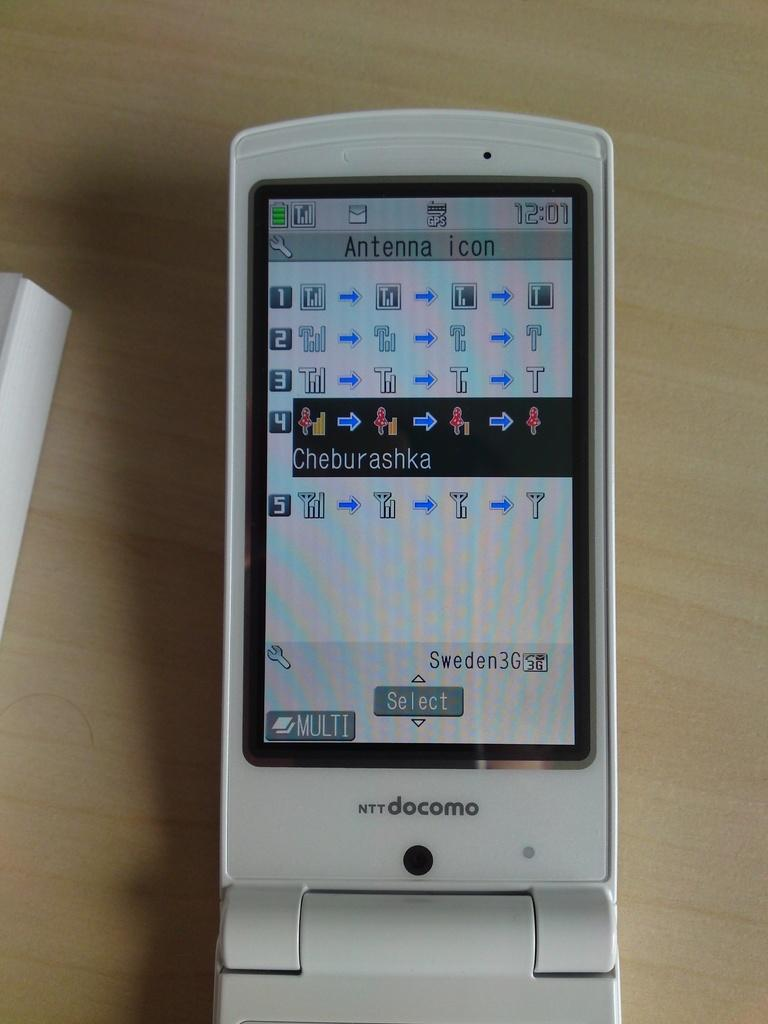Provide a one-sentence caption for the provided image. A cellphone is searching for the proper icon and choosing Cheburashka. 